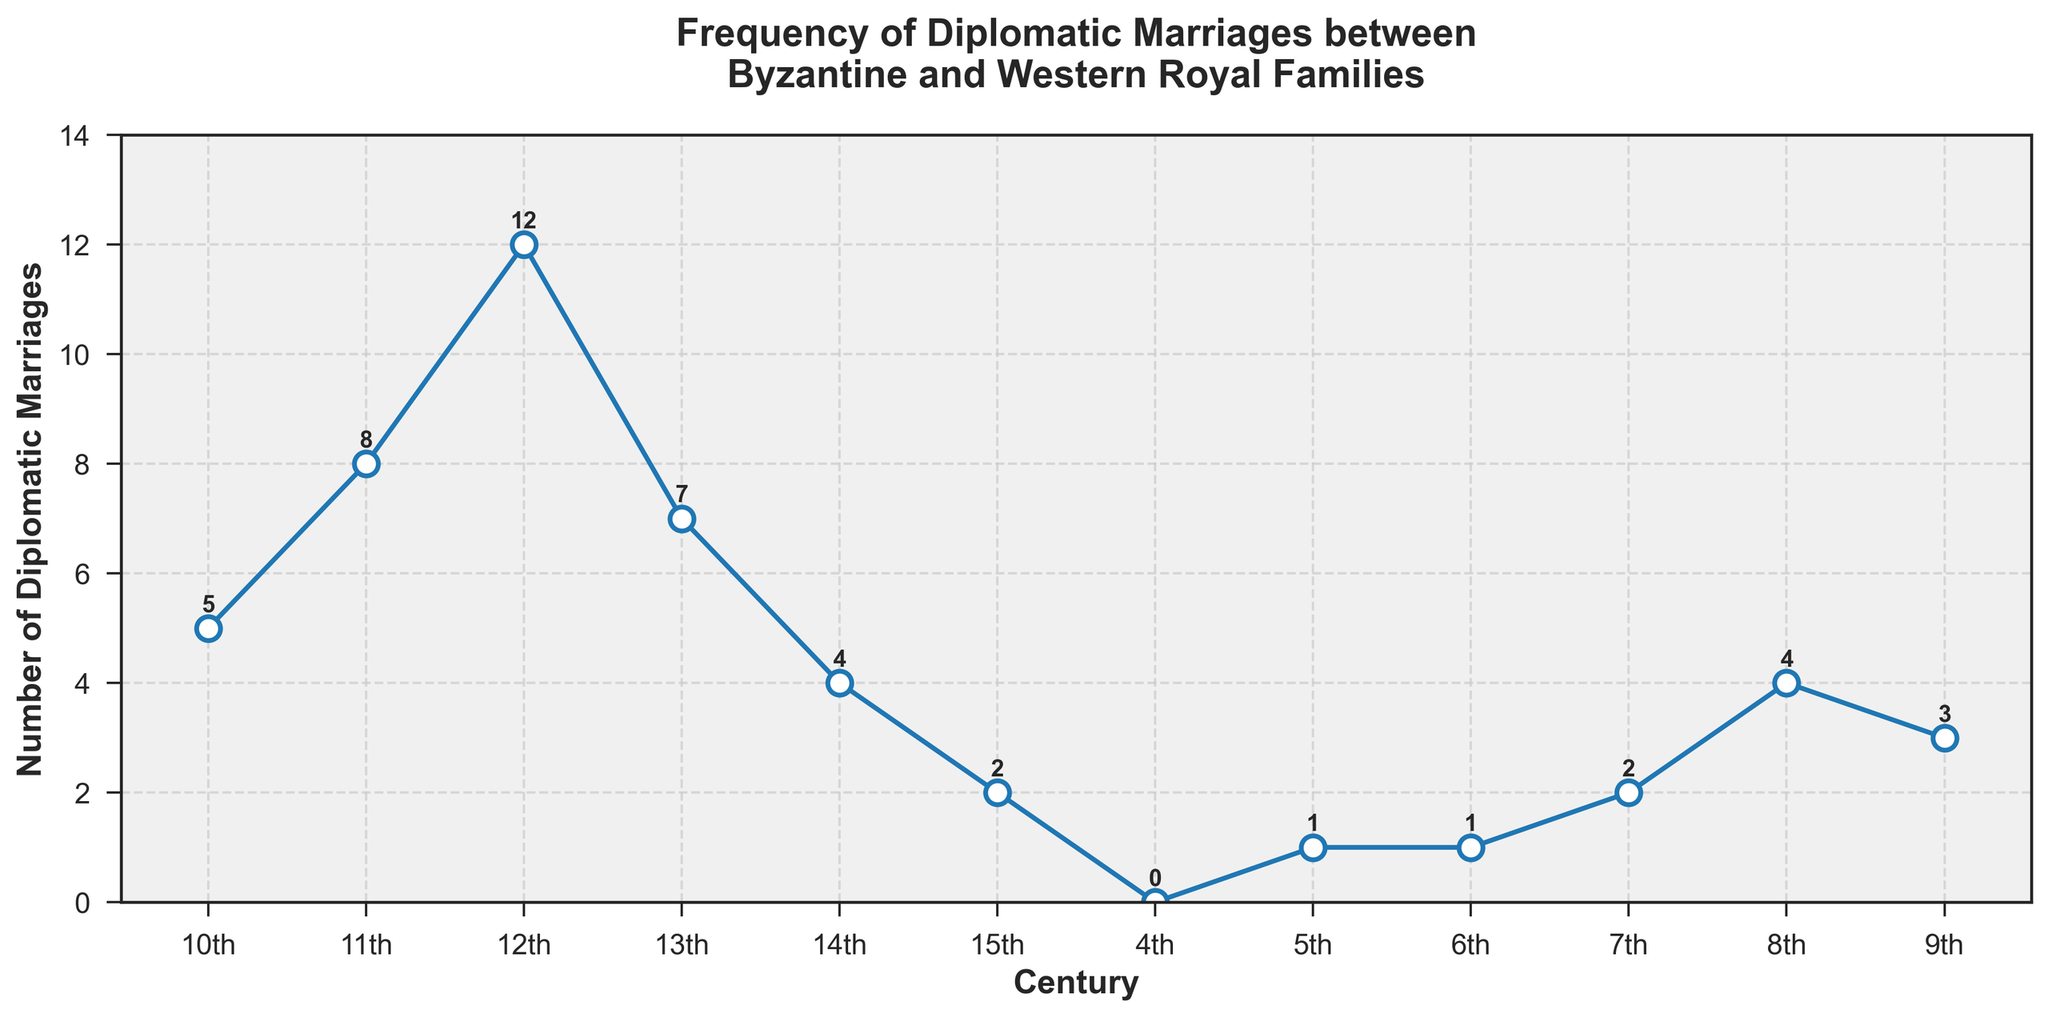What is the highest recorded number of diplomatic marriages in any century? By examining the plot, the highest point is in the 12th century, where the peak number of diplomatic marriages is indicated.
Answer: 12 How many diplomatic marriages occurred in the 11th century? Look at the data point corresponding to the 11th century on the x-axis and find the y-value associated with it.
Answer: 8 Which century has the least number of recorded diplomatic marriages, and what is that number? The lowest data points appear in the 4th and 5th centuries, both showing zero and one diplomatic marriage, respectively. However, the 4th century has no diplomatic marriages at all.
Answer: 4th, 0 Between which two centuries was the greatest increase in diplomatic marriages observed, and what was the change? The graph shows a steep rise from the 10th to the 12th century. Specifically, diplomatic marriages increase from 5 in the 10th century to 12 in the 12th century. The change is 12 - 5 = 7.
Answer: 10th to 12th, 7 What is the trend of diplomatic marriages between the 14th and 15th century? The data points indicate a downward trend, as values drop from 4 in the 14th century to 2 in the 15th century.
Answer: downward Comparing the 8th century and the 11th century, in which century were more diplomatic marriages recorded, and by how much? The 8th century has 4, and the 11th century has 8 diplomatic marriages. The difference is 8 - 4 = 4.
Answer: 11th, 4 What is the sum of all diplomatic marriages in the 9th and 13th centuries? Look at the numbers in the 9th (3) and 13th (7) centuries. Add them together: 3 + 7 = 10.
Answer: 10 If we wanted to calculate the average number of diplomatic marriages from the 6th to 10th centuries, what would it be? First sum the marriages: 6th (1) + 7th (2) + 8th (4) + 9th (3) + 10th (5) = 15. Then divide by the number of centuries (5): 15 / 5 = 3.
Answer: 3 